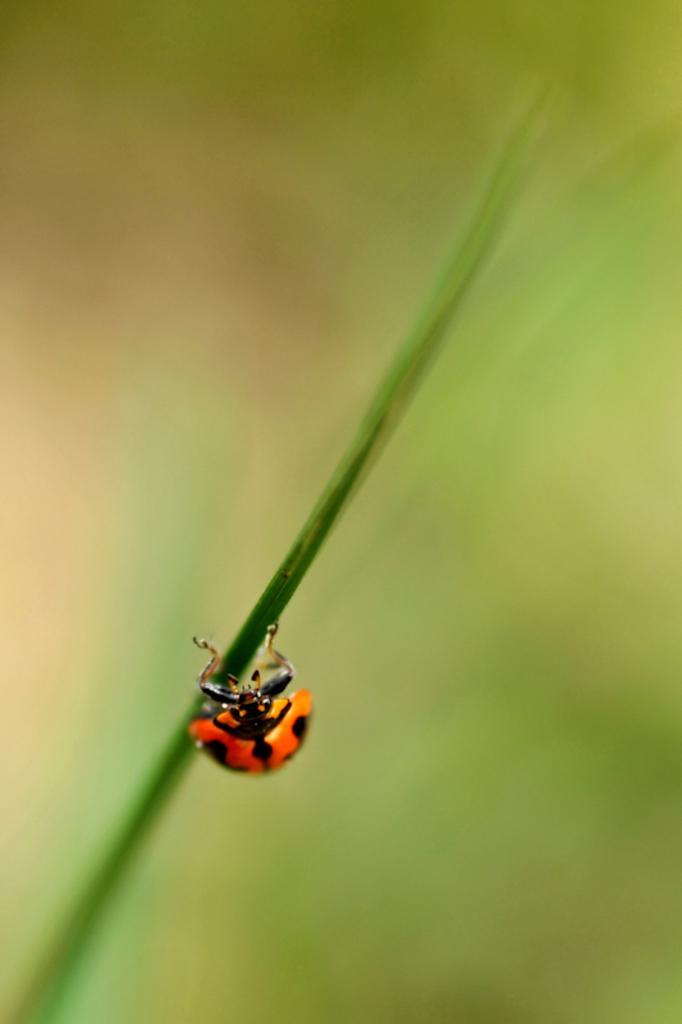How would you summarize this image in a sentence or two? In this picture, we see an insect in red color is on the plant. In the background, it is green in color. It is blurred in the background. 